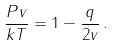Convert formula to latex. <formula><loc_0><loc_0><loc_500><loc_500>\frac { P v } { k T } = 1 - \frac { q } { 2 v } \, .</formula> 